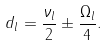<formula> <loc_0><loc_0><loc_500><loc_500>d _ { l } = \frac { \nu _ { l } } { 2 } \pm \frac { \Omega _ { l } } { 4 } .</formula> 